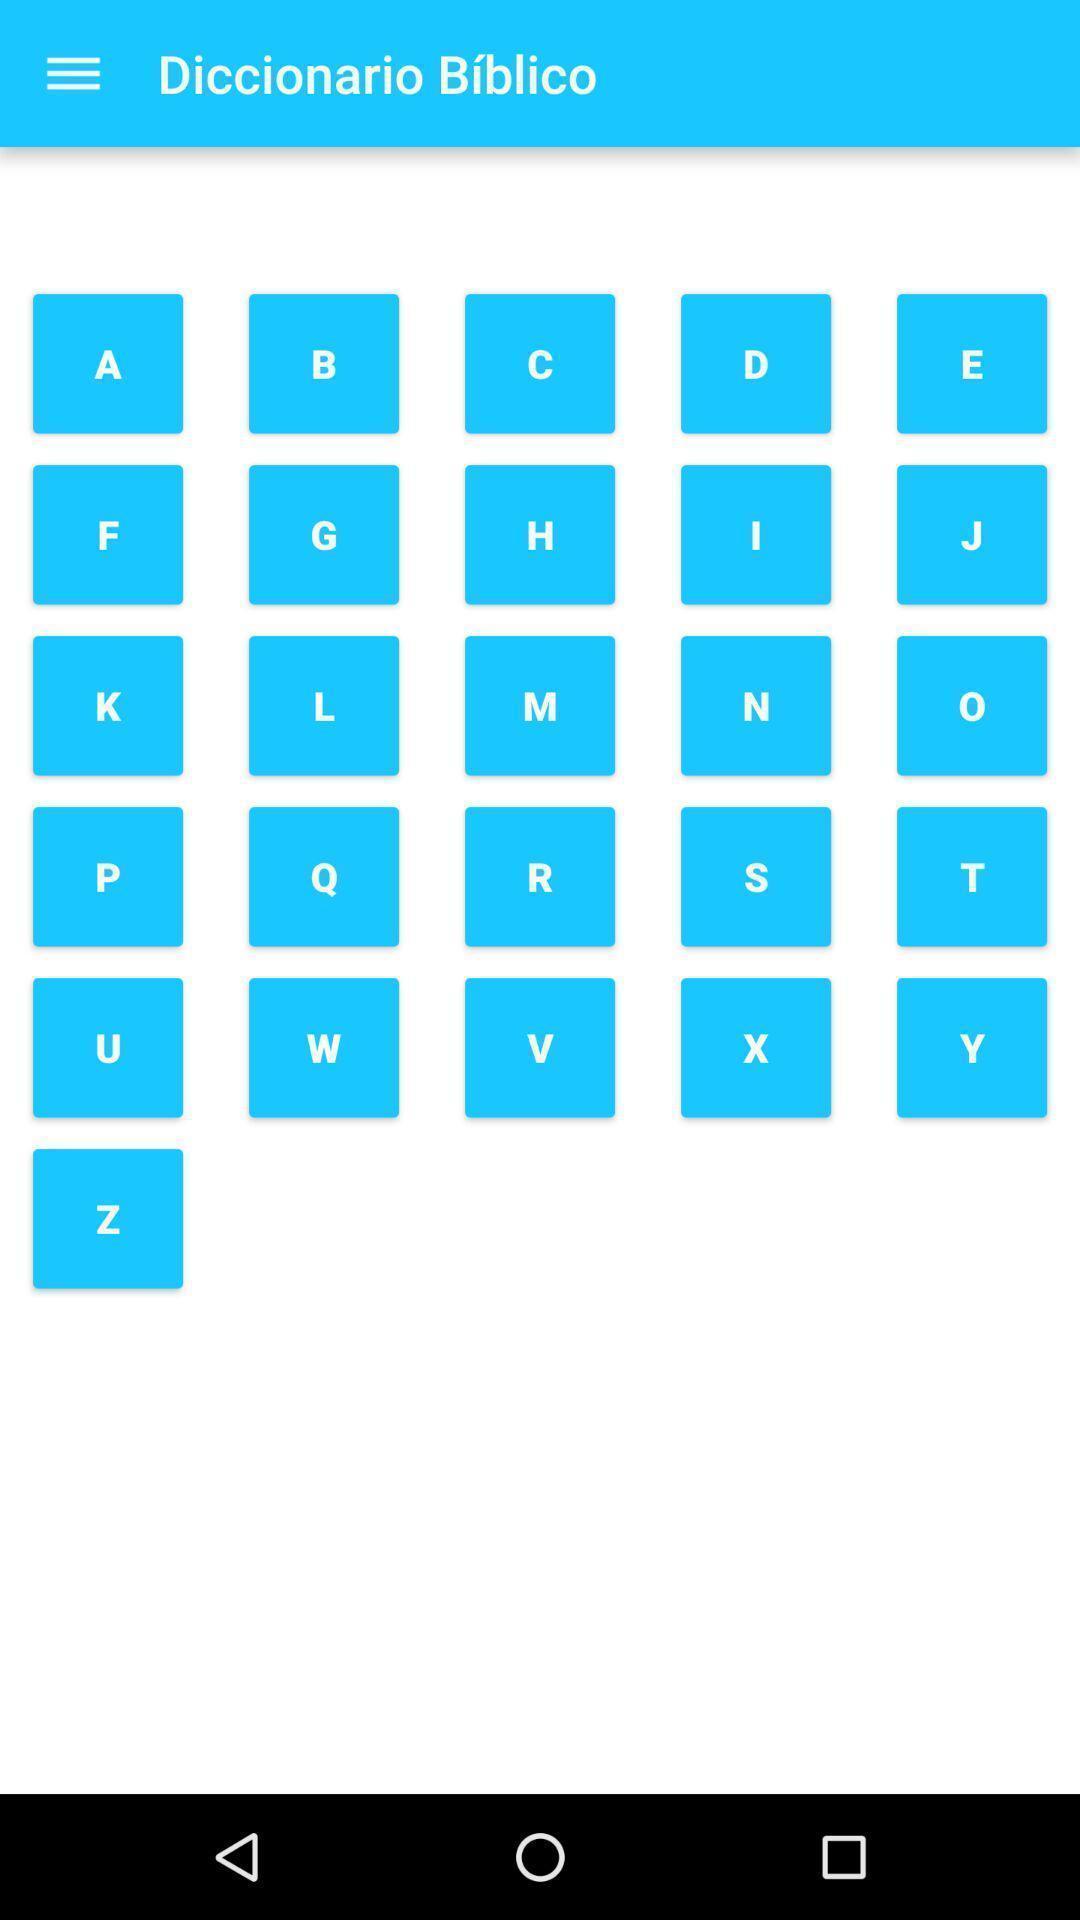Describe the visual elements of this screenshot. Screen displaying a list of alphabet icons. 